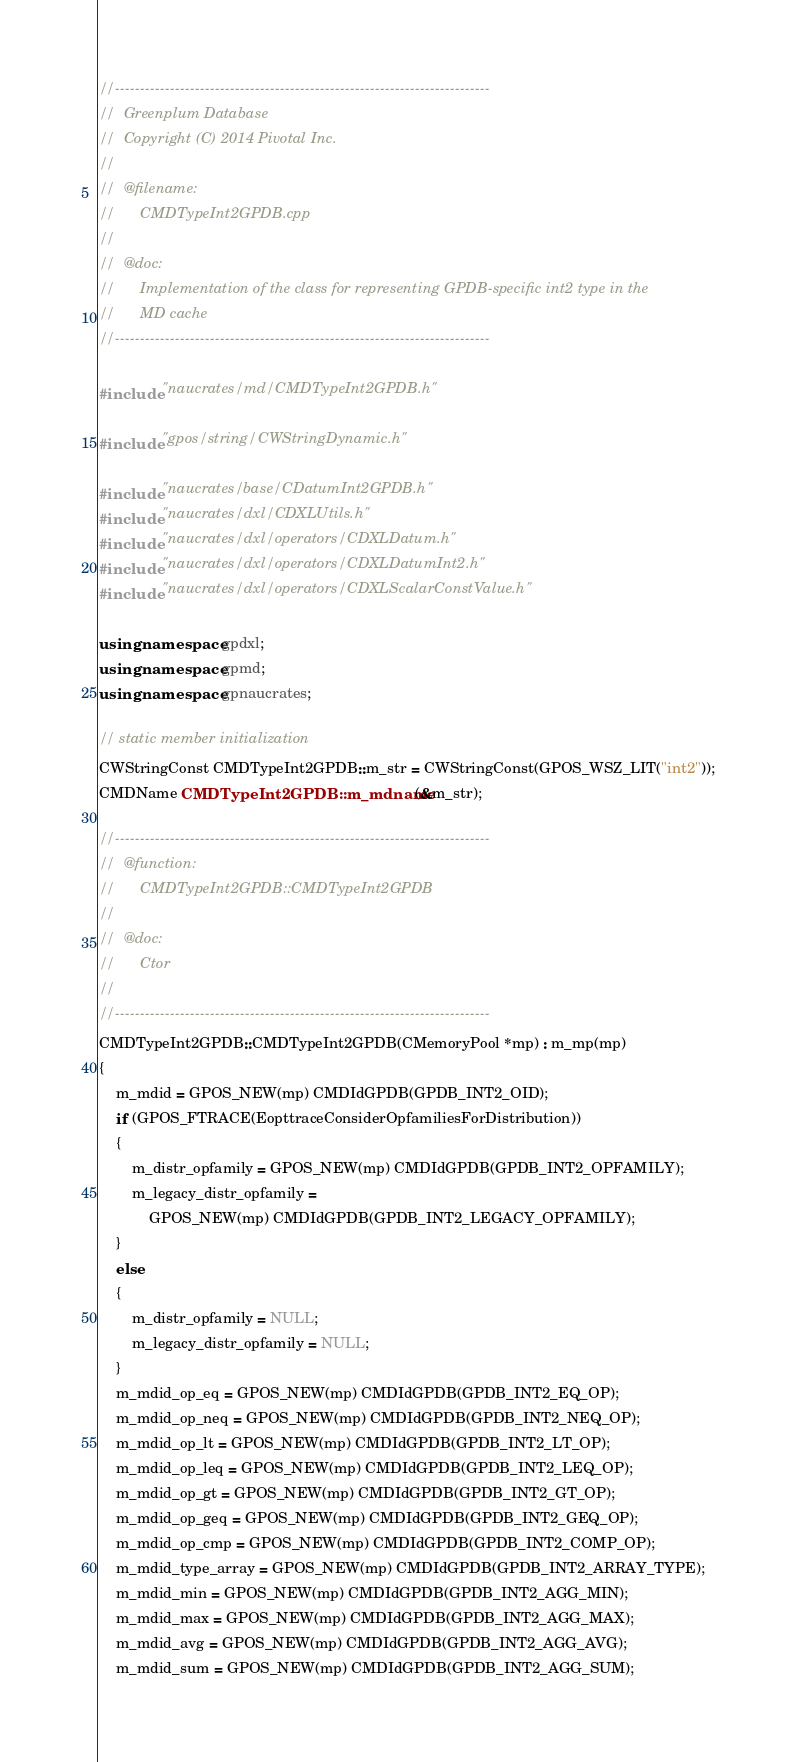<code> <loc_0><loc_0><loc_500><loc_500><_C++_>//---------------------------------------------------------------------------
//	Greenplum Database
//	Copyright (C) 2014 Pivotal Inc.
//
//	@filename:
//		CMDTypeInt2GPDB.cpp
//
//	@doc:
//		Implementation of the class for representing GPDB-specific int2 type in the
//		MD cache
//---------------------------------------------------------------------------

#include "naucrates/md/CMDTypeInt2GPDB.h"

#include "gpos/string/CWStringDynamic.h"

#include "naucrates/base/CDatumInt2GPDB.h"
#include "naucrates/dxl/CDXLUtils.h"
#include "naucrates/dxl/operators/CDXLDatum.h"
#include "naucrates/dxl/operators/CDXLDatumInt2.h"
#include "naucrates/dxl/operators/CDXLScalarConstValue.h"

using namespace gpdxl;
using namespace gpmd;
using namespace gpnaucrates;

// static member initialization
CWStringConst CMDTypeInt2GPDB::m_str = CWStringConst(GPOS_WSZ_LIT("int2"));
CMDName CMDTypeInt2GPDB::m_mdname(&m_str);

//---------------------------------------------------------------------------
//	@function:
//		CMDTypeInt2GPDB::CMDTypeInt2GPDB
//
//	@doc:
//		Ctor
//
//---------------------------------------------------------------------------
CMDTypeInt2GPDB::CMDTypeInt2GPDB(CMemoryPool *mp) : m_mp(mp)
{
	m_mdid = GPOS_NEW(mp) CMDIdGPDB(GPDB_INT2_OID);
	if (GPOS_FTRACE(EopttraceConsiderOpfamiliesForDistribution))
	{
		m_distr_opfamily = GPOS_NEW(mp) CMDIdGPDB(GPDB_INT2_OPFAMILY);
		m_legacy_distr_opfamily =
			GPOS_NEW(mp) CMDIdGPDB(GPDB_INT2_LEGACY_OPFAMILY);
	}
	else
	{
		m_distr_opfamily = NULL;
		m_legacy_distr_opfamily = NULL;
	}
	m_mdid_op_eq = GPOS_NEW(mp) CMDIdGPDB(GPDB_INT2_EQ_OP);
	m_mdid_op_neq = GPOS_NEW(mp) CMDIdGPDB(GPDB_INT2_NEQ_OP);
	m_mdid_op_lt = GPOS_NEW(mp) CMDIdGPDB(GPDB_INT2_LT_OP);
	m_mdid_op_leq = GPOS_NEW(mp) CMDIdGPDB(GPDB_INT2_LEQ_OP);
	m_mdid_op_gt = GPOS_NEW(mp) CMDIdGPDB(GPDB_INT2_GT_OP);
	m_mdid_op_geq = GPOS_NEW(mp) CMDIdGPDB(GPDB_INT2_GEQ_OP);
	m_mdid_op_cmp = GPOS_NEW(mp) CMDIdGPDB(GPDB_INT2_COMP_OP);
	m_mdid_type_array = GPOS_NEW(mp) CMDIdGPDB(GPDB_INT2_ARRAY_TYPE);
	m_mdid_min = GPOS_NEW(mp) CMDIdGPDB(GPDB_INT2_AGG_MIN);
	m_mdid_max = GPOS_NEW(mp) CMDIdGPDB(GPDB_INT2_AGG_MAX);
	m_mdid_avg = GPOS_NEW(mp) CMDIdGPDB(GPDB_INT2_AGG_AVG);
	m_mdid_sum = GPOS_NEW(mp) CMDIdGPDB(GPDB_INT2_AGG_SUM);</code> 